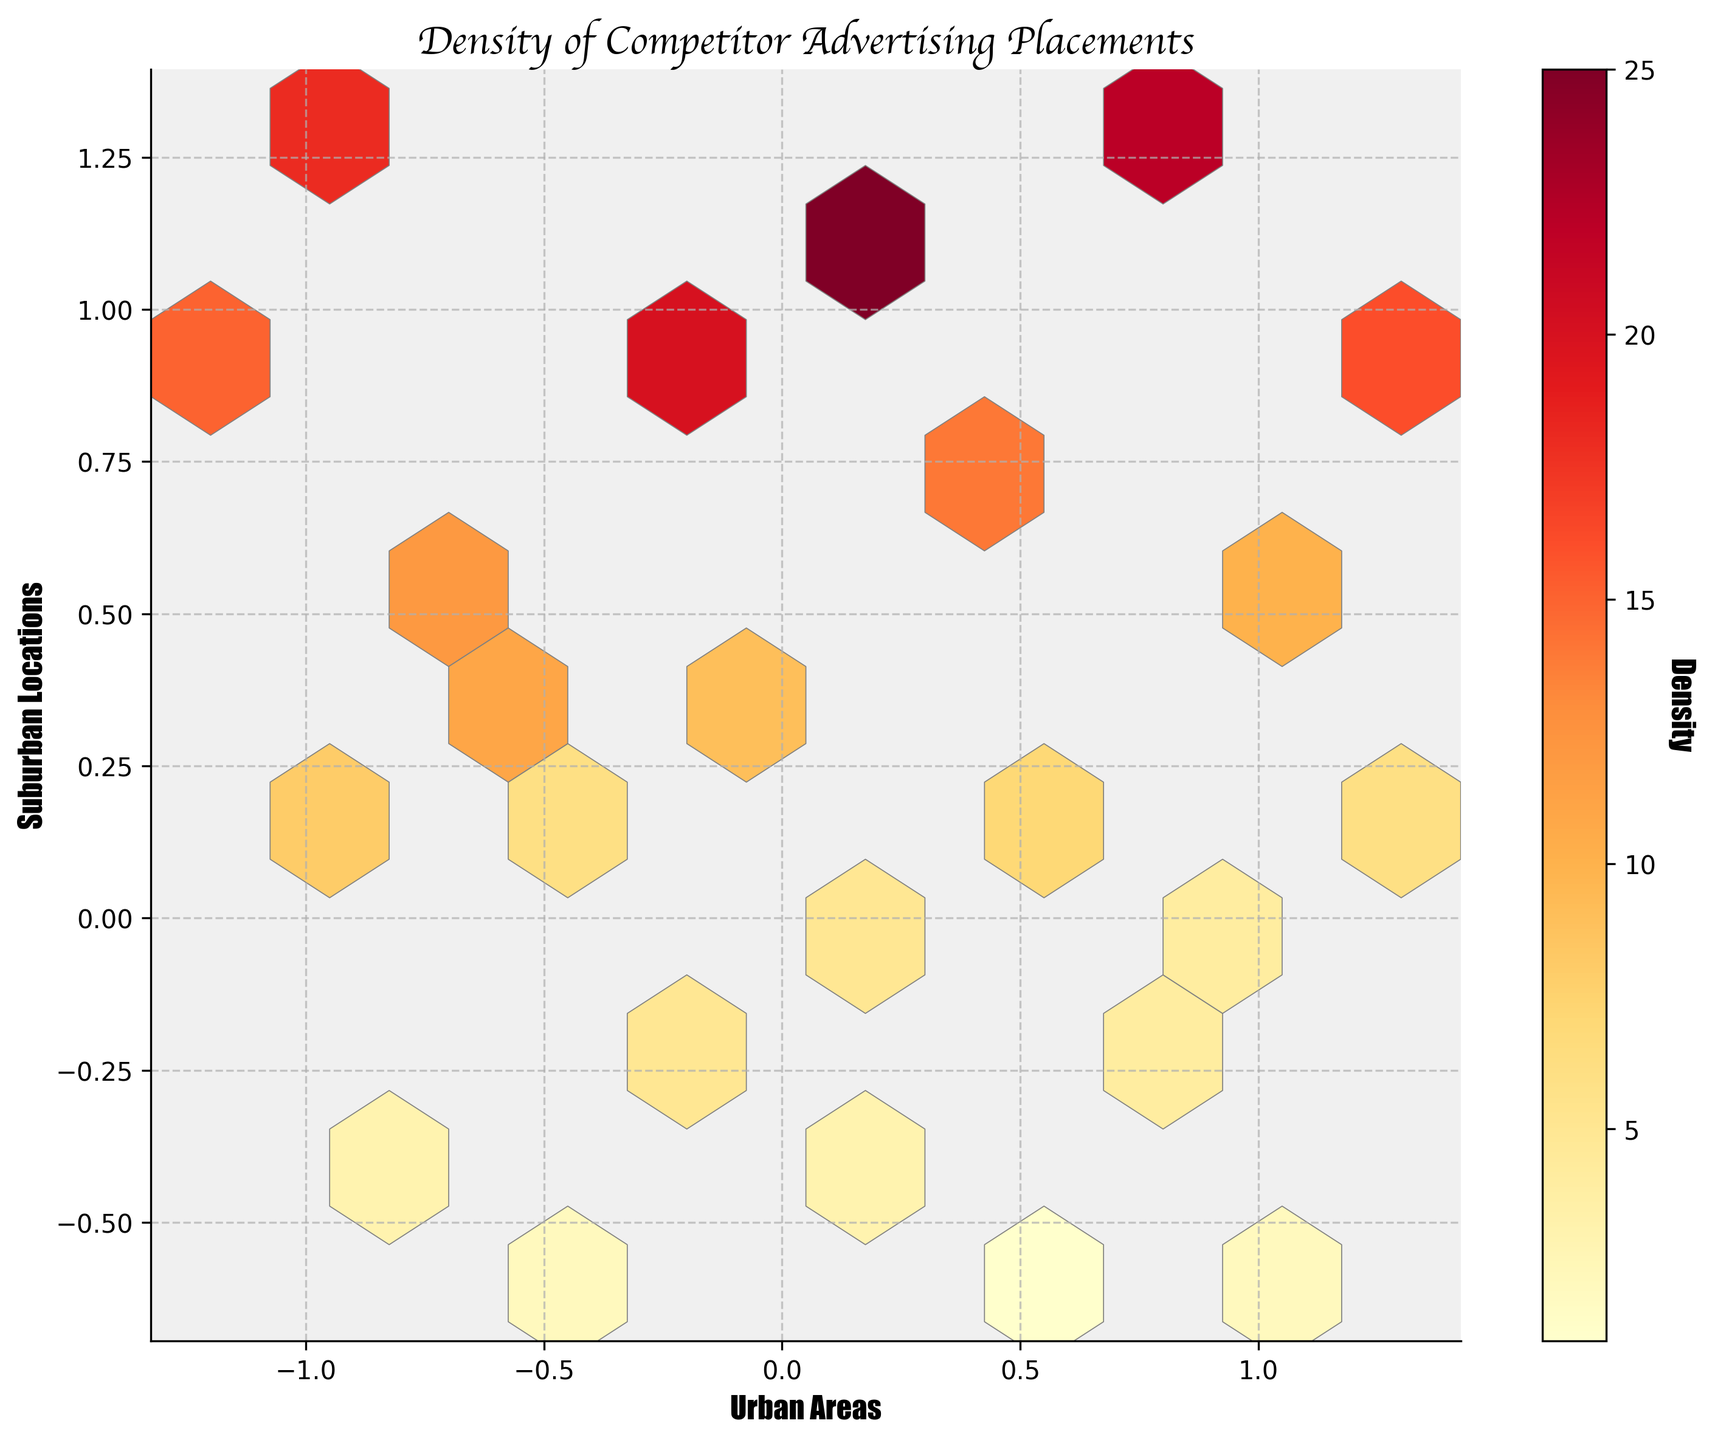What is the title of the hexbin plot? The title of the hexbin plot can be found at the top of the figure. It reads "Density of Competitor Advertising Placements."
Answer: Density of Competitor Advertising Placements What is the color used for the density gradient? The color gradient used to represent the density ranges from yellow to red, indicating the "YlOrRd" color map.
Answer: Yellow to Red What do the x and y axes represent? The labels of the axes indicate that the x-axis represents "Urban Areas" and the y-axis represents "Suburban Locations."
Answer: Urban Areas and Suburban Locations Which location type has the highest density of advertising placements? By observing the density color gradient, the highest density areas will be red or very dark orange. These high-density points appear closer to suburban locations on the y-axis.
Answer: Suburban Locations Is there a significant density difference between the areas near (0.1, 1.1) and (0.2, -0.4)? Looking at the density values and corresponding colors, near (0.1, 1.1) there is a higher density (around dark orange to red), whereas near (0.2, -0.4) it shows a lower density (yellow). This indicates a significant difference.
Answer: Yes Which corner (top-left, top-right, bottom-left, bottom-right) of the hexbin plot has the least advertising density? Observing the color gradient in the corners of the plot, the bottom-right corner (positive x and negative y value region) has mostly lighter colors, indicating lower density.
Answer: Bottom-right Does the plot have a color bar, and if so, what is its label? The figure includes a color bar to the side which helps to interpret the density values, and it is labeled "Density."
Answer: Yes, Density What grid size is used to plot the hexagons? The grid size of the hexagons, indicating how finely the data is binned, appears to be divided into approximately 10 discrete bins along each axis as observed from their arrangement.
Answer: 10 How does the density at (1.3, 1.0) compare to the density at (-0.9, 1.2)? Comparing the densities visually, (1.3, 1.0) is in a moderate density area (probably light orange) while (-0.9, 1.2) is in a higher density area (possibly dark orange). This indicates density at (-0.9, 1.2) is higher.
Answer: Higher at (-0.9, 1.2) Does the plot visually suggest any particular trend between urban and suburban advertisement densities? Observing the plot, higher densities seem to align along the y-axis indicating a trend where suburban areas (higher y-values) have more competitor advertising placements compared to urban areas.
Answer: Yes, more densities in suburban locations 